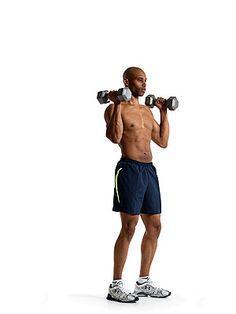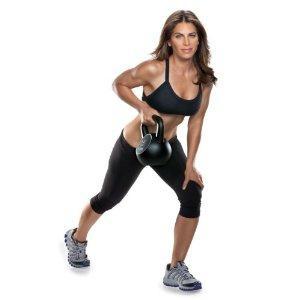The first image is the image on the left, the second image is the image on the right. Given the left and right images, does the statement "An image shows a girl in sports bra and short black shorts doing a lunge without a mat while holding dumbbells." hold true? Answer yes or no. No. 